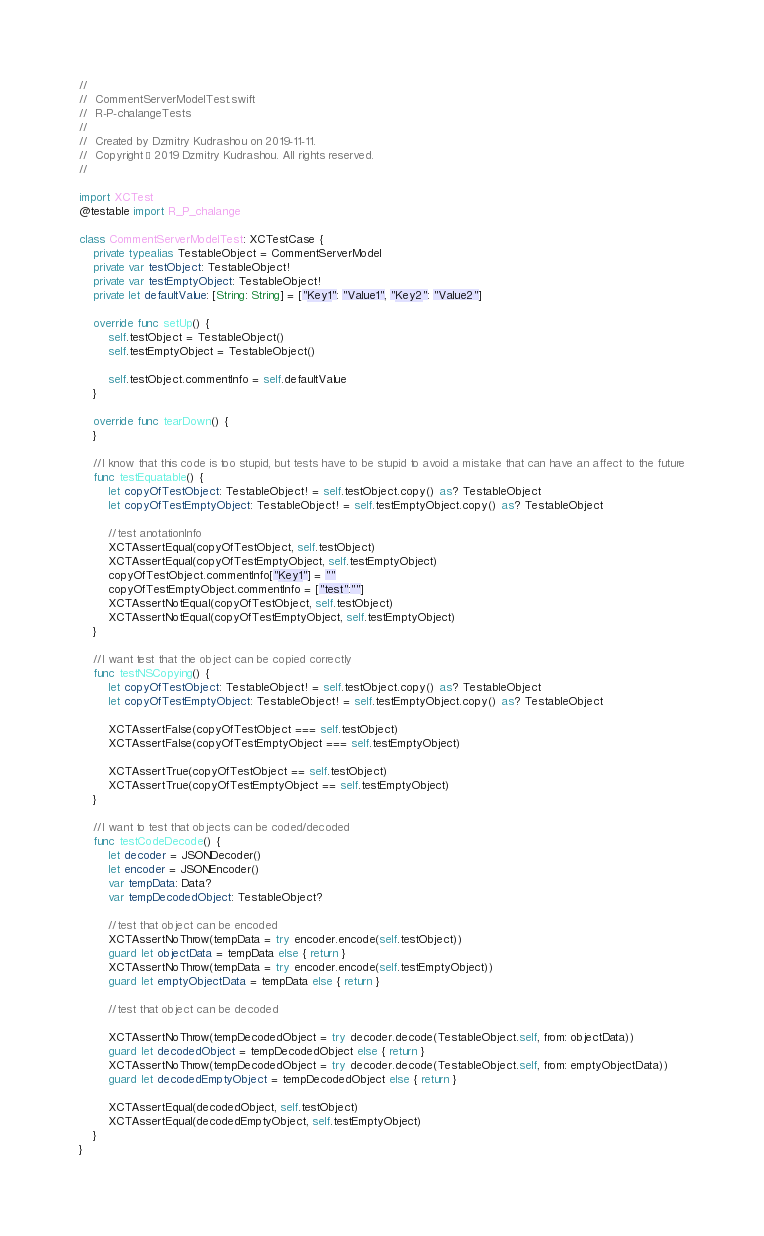<code> <loc_0><loc_0><loc_500><loc_500><_Swift_>//
//  CommentServerModelTest.swift
//  R-P-chalangeTests
//
//  Created by Dzmitry Kudrashou on 2019-11-11.
//  Copyright © 2019 Dzmitry Kudrashou. All rights reserved.
//

import XCTest
@testable import R_P_chalange

class CommentServerModelTest: XCTestCase {
    private typealias TestableObject = CommentServerModel
	private var testObject: TestableObject!
	private var testEmptyObject: TestableObject!
	private let defaultValue: [String: String] = ["Key1": "Value1", "Key2": "Value2"]
	
    override func setUp() {
		self.testObject = TestableObject()
		self.testEmptyObject = TestableObject()
		
		self.testObject.commentInfo = self.defaultValue
    }

    override func tearDown() {
    }

	//I know that this code is too stupid, but tests have to be stupid to avoid a mistake that can have an affect to the future
	func testEquatable() {
		let copyOfTestObject: TestableObject! = self.testObject.copy() as? TestableObject
		let copyOfTestEmptyObject: TestableObject! = self.testEmptyObject.copy() as? TestableObject
		
		//test anotationInfo
		XCTAssertEqual(copyOfTestObject, self.testObject)
		XCTAssertEqual(copyOfTestEmptyObject, self.testEmptyObject)
		copyOfTestObject.commentInfo["Key1"] = ""
		copyOfTestEmptyObject.commentInfo = ["test":""]
		XCTAssertNotEqual(copyOfTestObject, self.testObject)
		XCTAssertNotEqual(copyOfTestEmptyObject, self.testEmptyObject)
	}
	
	//I want test that the object can be copied correctly
	func testNSCopying() {
		let copyOfTestObject: TestableObject! = self.testObject.copy() as? TestableObject
		let copyOfTestEmptyObject: TestableObject! = self.testEmptyObject.copy() as? TestableObject
		
		XCTAssertFalse(copyOfTestObject === self.testObject)
		XCTAssertFalse(copyOfTestEmptyObject === self.testEmptyObject)
		
		XCTAssertTrue(copyOfTestObject == self.testObject)
		XCTAssertTrue(copyOfTestEmptyObject == self.testEmptyObject)
	}

	//I want to test that objects can be coded/decoded
	func testCodeDecode() {
		let decoder = JSONDecoder()
		let encoder = JSONEncoder()
		var tempData: Data?
		var tempDecodedObject: TestableObject?
		
		//test that object can be encoded
		XCTAssertNoThrow(tempData = try encoder.encode(self.testObject))
		guard let objectData = tempData else { return }
		XCTAssertNoThrow(tempData = try encoder.encode(self.testEmptyObject))
		guard let emptyObjectData = tempData else { return }
		
		//test that object can be decoded
		
		XCTAssertNoThrow(tempDecodedObject = try decoder.decode(TestableObject.self, from: objectData))
		guard let decodedObject = tempDecodedObject else { return }
		XCTAssertNoThrow(tempDecodedObject = try decoder.decode(TestableObject.self, from: emptyObjectData))
		guard let decodedEmptyObject = tempDecodedObject else { return }
		
		XCTAssertEqual(decodedObject, self.testObject)
		XCTAssertEqual(decodedEmptyObject, self.testEmptyObject)
	}
}
</code> 